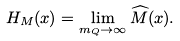<formula> <loc_0><loc_0><loc_500><loc_500>H _ { M } ( x ) = \lim _ { m _ { Q } \to \infty } \widehat { M } ( x ) .</formula> 